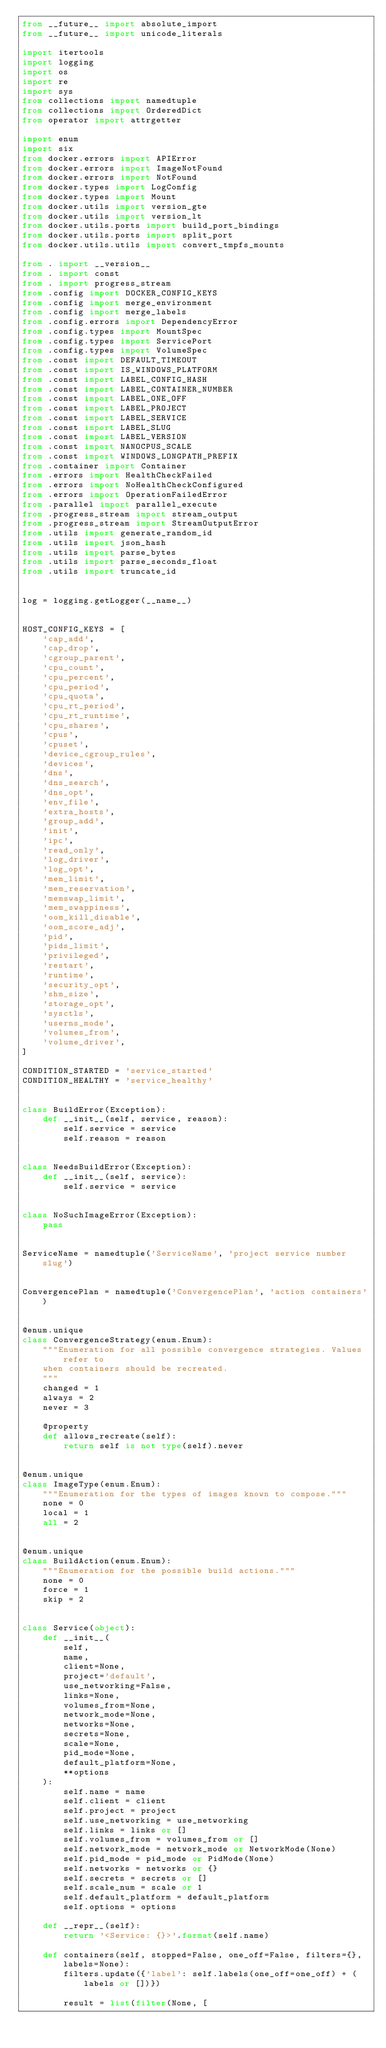Convert code to text. <code><loc_0><loc_0><loc_500><loc_500><_Python_>from __future__ import absolute_import
from __future__ import unicode_literals

import itertools
import logging
import os
import re
import sys
from collections import namedtuple
from collections import OrderedDict
from operator import attrgetter

import enum
import six
from docker.errors import APIError
from docker.errors import ImageNotFound
from docker.errors import NotFound
from docker.types import LogConfig
from docker.types import Mount
from docker.utils import version_gte
from docker.utils import version_lt
from docker.utils.ports import build_port_bindings
from docker.utils.ports import split_port
from docker.utils.utils import convert_tmpfs_mounts

from . import __version__
from . import const
from . import progress_stream
from .config import DOCKER_CONFIG_KEYS
from .config import merge_environment
from .config import merge_labels
from .config.errors import DependencyError
from .config.types import MountSpec
from .config.types import ServicePort
from .config.types import VolumeSpec
from .const import DEFAULT_TIMEOUT
from .const import IS_WINDOWS_PLATFORM
from .const import LABEL_CONFIG_HASH
from .const import LABEL_CONTAINER_NUMBER
from .const import LABEL_ONE_OFF
from .const import LABEL_PROJECT
from .const import LABEL_SERVICE
from .const import LABEL_SLUG
from .const import LABEL_VERSION
from .const import NANOCPUS_SCALE
from .const import WINDOWS_LONGPATH_PREFIX
from .container import Container
from .errors import HealthCheckFailed
from .errors import NoHealthCheckConfigured
from .errors import OperationFailedError
from .parallel import parallel_execute
from .progress_stream import stream_output
from .progress_stream import StreamOutputError
from .utils import generate_random_id
from .utils import json_hash
from .utils import parse_bytes
from .utils import parse_seconds_float
from .utils import truncate_id


log = logging.getLogger(__name__)


HOST_CONFIG_KEYS = [
    'cap_add',
    'cap_drop',
    'cgroup_parent',
    'cpu_count',
    'cpu_percent',
    'cpu_period',
    'cpu_quota',
    'cpu_rt_period',
    'cpu_rt_runtime',
    'cpu_shares',
    'cpus',
    'cpuset',
    'device_cgroup_rules',
    'devices',
    'dns',
    'dns_search',
    'dns_opt',
    'env_file',
    'extra_hosts',
    'group_add',
    'init',
    'ipc',
    'read_only',
    'log_driver',
    'log_opt',
    'mem_limit',
    'mem_reservation',
    'memswap_limit',
    'mem_swappiness',
    'oom_kill_disable',
    'oom_score_adj',
    'pid',
    'pids_limit',
    'privileged',
    'restart',
    'runtime',
    'security_opt',
    'shm_size',
    'storage_opt',
    'sysctls',
    'userns_mode',
    'volumes_from',
    'volume_driver',
]

CONDITION_STARTED = 'service_started'
CONDITION_HEALTHY = 'service_healthy'


class BuildError(Exception):
    def __init__(self, service, reason):
        self.service = service
        self.reason = reason


class NeedsBuildError(Exception):
    def __init__(self, service):
        self.service = service


class NoSuchImageError(Exception):
    pass


ServiceName = namedtuple('ServiceName', 'project service number slug')


ConvergencePlan = namedtuple('ConvergencePlan', 'action containers')


@enum.unique
class ConvergenceStrategy(enum.Enum):
    """Enumeration for all possible convergence strategies. Values refer to
    when containers should be recreated.
    """
    changed = 1
    always = 2
    never = 3

    @property
    def allows_recreate(self):
        return self is not type(self).never


@enum.unique
class ImageType(enum.Enum):
    """Enumeration for the types of images known to compose."""
    none = 0
    local = 1
    all = 2


@enum.unique
class BuildAction(enum.Enum):
    """Enumeration for the possible build actions."""
    none = 0
    force = 1
    skip = 2


class Service(object):
    def __init__(
        self,
        name,
        client=None,
        project='default',
        use_networking=False,
        links=None,
        volumes_from=None,
        network_mode=None,
        networks=None,
        secrets=None,
        scale=None,
        pid_mode=None,
        default_platform=None,
        **options
    ):
        self.name = name
        self.client = client
        self.project = project
        self.use_networking = use_networking
        self.links = links or []
        self.volumes_from = volumes_from or []
        self.network_mode = network_mode or NetworkMode(None)
        self.pid_mode = pid_mode or PidMode(None)
        self.networks = networks or {}
        self.secrets = secrets or []
        self.scale_num = scale or 1
        self.default_platform = default_platform
        self.options = options

    def __repr__(self):
        return '<Service: {}>'.format(self.name)

    def containers(self, stopped=False, one_off=False, filters={}, labels=None):
        filters.update({'label': self.labels(one_off=one_off) + (labels or [])})

        result = list(filter(None, [</code> 